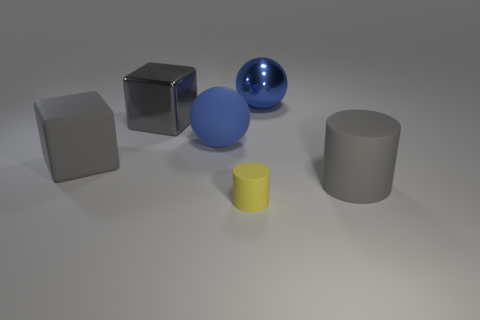There is a matte cylinder that is the same size as the rubber block; what is its color?
Ensure brevity in your answer.  Gray. How many objects are either large gray rubber objects to the left of the blue matte sphere or gray cubes that are behind the gray matte cube?
Your answer should be very brief. 2. Is the number of metal balls that are on the left side of the small yellow object the same as the number of large gray cubes?
Keep it short and to the point. No. There is a gray rubber object that is on the right side of the matte cube; does it have the same size as the blue object on the left side of the big blue metallic ball?
Offer a terse response. Yes. What number of other objects are there of the same size as the gray cylinder?
Provide a short and direct response. 4. Is there a small rubber cylinder that is behind the large blue ball in front of the blue ball that is behind the large rubber ball?
Offer a very short reply. No. Is there any other thing that has the same color as the shiny ball?
Provide a short and direct response. Yes. There is a ball on the right side of the tiny yellow thing; how big is it?
Keep it short and to the point. Large. How big is the cube behind the big rubber thing behind the gray rubber thing behind the large cylinder?
Your response must be concise. Large. What color is the large ball that is behind the large blue ball to the left of the yellow rubber cylinder?
Offer a terse response. Blue. 